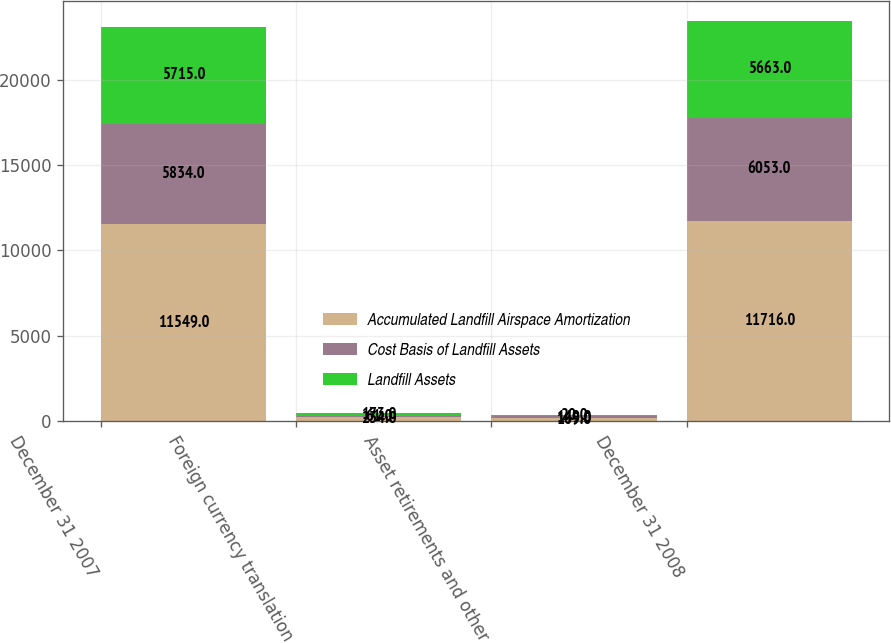Convert chart to OTSL. <chart><loc_0><loc_0><loc_500><loc_500><stacked_bar_chart><ecel><fcel>December 31 2007<fcel>Foreign currency translation<fcel>Asset retirements and other<fcel>December 31 2008<nl><fcel>Accumulated Landfill Airspace Amortization<fcel>11549<fcel>234<fcel>169<fcel>11716<nl><fcel>Cost Basis of Landfill Assets<fcel>5834<fcel>61<fcel>149<fcel>6053<nl><fcel>Landfill Assets<fcel>5715<fcel>173<fcel>20<fcel>5663<nl></chart> 